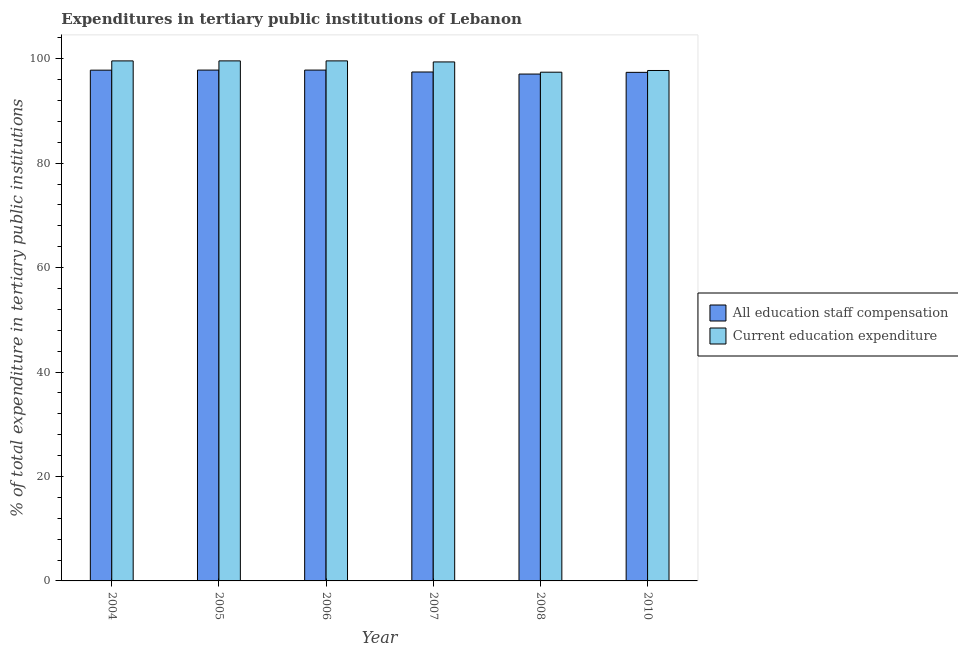How many different coloured bars are there?
Provide a succinct answer. 2. How many bars are there on the 5th tick from the left?
Ensure brevity in your answer.  2. In how many cases, is the number of bars for a given year not equal to the number of legend labels?
Offer a very short reply. 0. What is the expenditure in education in 2008?
Your answer should be very brief. 97.41. Across all years, what is the maximum expenditure in staff compensation?
Keep it short and to the point. 97.81. Across all years, what is the minimum expenditure in staff compensation?
Your response must be concise. 97.05. In which year was the expenditure in staff compensation maximum?
Your answer should be compact. 2005. What is the total expenditure in education in the graph?
Provide a succinct answer. 593.24. What is the difference between the expenditure in education in 2005 and that in 2010?
Your answer should be very brief. 1.84. What is the difference between the expenditure in education in 2005 and the expenditure in staff compensation in 2010?
Your answer should be very brief. 1.84. What is the average expenditure in education per year?
Make the answer very short. 98.87. What is the ratio of the expenditure in education in 2006 to that in 2008?
Ensure brevity in your answer.  1.02. Is the expenditure in staff compensation in 2004 less than that in 2006?
Provide a succinct answer. Yes. Is the difference between the expenditure in staff compensation in 2006 and 2007 greater than the difference between the expenditure in education in 2006 and 2007?
Offer a very short reply. No. What is the difference between the highest and the second highest expenditure in education?
Your answer should be very brief. 0. What is the difference between the highest and the lowest expenditure in education?
Your response must be concise. 2.17. What does the 2nd bar from the left in 2010 represents?
Offer a terse response. Current education expenditure. What does the 1st bar from the right in 2008 represents?
Offer a terse response. Current education expenditure. Are all the bars in the graph horizontal?
Provide a short and direct response. No. What is the difference between two consecutive major ticks on the Y-axis?
Provide a succinct answer. 20. Are the values on the major ticks of Y-axis written in scientific E-notation?
Your answer should be very brief. No. Does the graph contain any zero values?
Give a very brief answer. No. Does the graph contain grids?
Your answer should be compact. No. Where does the legend appear in the graph?
Provide a short and direct response. Center right. How many legend labels are there?
Provide a succinct answer. 2. How are the legend labels stacked?
Your response must be concise. Vertical. What is the title of the graph?
Offer a terse response. Expenditures in tertiary public institutions of Lebanon. Does "Frequency of shipment arrival" appear as one of the legend labels in the graph?
Make the answer very short. No. What is the label or title of the Y-axis?
Provide a short and direct response. % of total expenditure in tertiary public institutions. What is the % of total expenditure in tertiary public institutions in All education staff compensation in 2004?
Your response must be concise. 97.8. What is the % of total expenditure in tertiary public institutions in Current education expenditure in 2004?
Keep it short and to the point. 99.57. What is the % of total expenditure in tertiary public institutions in All education staff compensation in 2005?
Provide a succinct answer. 97.81. What is the % of total expenditure in tertiary public institutions of Current education expenditure in 2005?
Your response must be concise. 99.58. What is the % of total expenditure in tertiary public institutions in All education staff compensation in 2006?
Make the answer very short. 97.81. What is the % of total expenditure in tertiary public institutions in Current education expenditure in 2006?
Provide a succinct answer. 99.58. What is the % of total expenditure in tertiary public institutions in All education staff compensation in 2007?
Offer a very short reply. 97.45. What is the % of total expenditure in tertiary public institutions in Current education expenditure in 2007?
Your answer should be very brief. 99.38. What is the % of total expenditure in tertiary public institutions of All education staff compensation in 2008?
Make the answer very short. 97.05. What is the % of total expenditure in tertiary public institutions in Current education expenditure in 2008?
Offer a terse response. 97.41. What is the % of total expenditure in tertiary public institutions of All education staff compensation in 2010?
Your answer should be very brief. 97.38. What is the % of total expenditure in tertiary public institutions in Current education expenditure in 2010?
Offer a terse response. 97.74. Across all years, what is the maximum % of total expenditure in tertiary public institutions in All education staff compensation?
Ensure brevity in your answer.  97.81. Across all years, what is the maximum % of total expenditure in tertiary public institutions of Current education expenditure?
Offer a terse response. 99.58. Across all years, what is the minimum % of total expenditure in tertiary public institutions in All education staff compensation?
Ensure brevity in your answer.  97.05. Across all years, what is the minimum % of total expenditure in tertiary public institutions in Current education expenditure?
Ensure brevity in your answer.  97.41. What is the total % of total expenditure in tertiary public institutions of All education staff compensation in the graph?
Give a very brief answer. 585.31. What is the total % of total expenditure in tertiary public institutions of Current education expenditure in the graph?
Keep it short and to the point. 593.24. What is the difference between the % of total expenditure in tertiary public institutions of All education staff compensation in 2004 and that in 2005?
Offer a terse response. -0.02. What is the difference between the % of total expenditure in tertiary public institutions of Current education expenditure in 2004 and that in 2005?
Offer a terse response. -0. What is the difference between the % of total expenditure in tertiary public institutions of All education staff compensation in 2004 and that in 2006?
Ensure brevity in your answer.  -0.02. What is the difference between the % of total expenditure in tertiary public institutions of Current education expenditure in 2004 and that in 2006?
Make the answer very short. -0. What is the difference between the % of total expenditure in tertiary public institutions of All education staff compensation in 2004 and that in 2007?
Offer a very short reply. 0.35. What is the difference between the % of total expenditure in tertiary public institutions in Current education expenditure in 2004 and that in 2007?
Offer a terse response. 0.2. What is the difference between the % of total expenditure in tertiary public institutions of All education staff compensation in 2004 and that in 2008?
Make the answer very short. 0.74. What is the difference between the % of total expenditure in tertiary public institutions in Current education expenditure in 2004 and that in 2008?
Your answer should be very brief. 2.17. What is the difference between the % of total expenditure in tertiary public institutions in All education staff compensation in 2004 and that in 2010?
Keep it short and to the point. 0.42. What is the difference between the % of total expenditure in tertiary public institutions of Current education expenditure in 2004 and that in 2010?
Your answer should be compact. 1.84. What is the difference between the % of total expenditure in tertiary public institutions in All education staff compensation in 2005 and that in 2006?
Give a very brief answer. 0. What is the difference between the % of total expenditure in tertiary public institutions in All education staff compensation in 2005 and that in 2007?
Ensure brevity in your answer.  0.37. What is the difference between the % of total expenditure in tertiary public institutions in Current education expenditure in 2005 and that in 2007?
Ensure brevity in your answer.  0.2. What is the difference between the % of total expenditure in tertiary public institutions in All education staff compensation in 2005 and that in 2008?
Your answer should be very brief. 0.76. What is the difference between the % of total expenditure in tertiary public institutions in Current education expenditure in 2005 and that in 2008?
Offer a very short reply. 2.17. What is the difference between the % of total expenditure in tertiary public institutions of All education staff compensation in 2005 and that in 2010?
Your answer should be compact. 0.43. What is the difference between the % of total expenditure in tertiary public institutions in Current education expenditure in 2005 and that in 2010?
Provide a short and direct response. 1.84. What is the difference between the % of total expenditure in tertiary public institutions in All education staff compensation in 2006 and that in 2007?
Provide a short and direct response. 0.37. What is the difference between the % of total expenditure in tertiary public institutions in Current education expenditure in 2006 and that in 2007?
Your response must be concise. 0.2. What is the difference between the % of total expenditure in tertiary public institutions of All education staff compensation in 2006 and that in 2008?
Your response must be concise. 0.76. What is the difference between the % of total expenditure in tertiary public institutions of Current education expenditure in 2006 and that in 2008?
Ensure brevity in your answer.  2.17. What is the difference between the % of total expenditure in tertiary public institutions of All education staff compensation in 2006 and that in 2010?
Give a very brief answer. 0.43. What is the difference between the % of total expenditure in tertiary public institutions in Current education expenditure in 2006 and that in 2010?
Ensure brevity in your answer.  1.84. What is the difference between the % of total expenditure in tertiary public institutions in All education staff compensation in 2007 and that in 2008?
Your response must be concise. 0.39. What is the difference between the % of total expenditure in tertiary public institutions of Current education expenditure in 2007 and that in 2008?
Provide a succinct answer. 1.97. What is the difference between the % of total expenditure in tertiary public institutions of All education staff compensation in 2007 and that in 2010?
Ensure brevity in your answer.  0.07. What is the difference between the % of total expenditure in tertiary public institutions of Current education expenditure in 2007 and that in 2010?
Your answer should be compact. 1.64. What is the difference between the % of total expenditure in tertiary public institutions in All education staff compensation in 2008 and that in 2010?
Your answer should be compact. -0.33. What is the difference between the % of total expenditure in tertiary public institutions in Current education expenditure in 2008 and that in 2010?
Offer a very short reply. -0.33. What is the difference between the % of total expenditure in tertiary public institutions in All education staff compensation in 2004 and the % of total expenditure in tertiary public institutions in Current education expenditure in 2005?
Offer a very short reply. -1.78. What is the difference between the % of total expenditure in tertiary public institutions of All education staff compensation in 2004 and the % of total expenditure in tertiary public institutions of Current education expenditure in 2006?
Keep it short and to the point. -1.78. What is the difference between the % of total expenditure in tertiary public institutions in All education staff compensation in 2004 and the % of total expenditure in tertiary public institutions in Current education expenditure in 2007?
Give a very brief answer. -1.58. What is the difference between the % of total expenditure in tertiary public institutions of All education staff compensation in 2004 and the % of total expenditure in tertiary public institutions of Current education expenditure in 2008?
Your answer should be very brief. 0.39. What is the difference between the % of total expenditure in tertiary public institutions in All education staff compensation in 2004 and the % of total expenditure in tertiary public institutions in Current education expenditure in 2010?
Offer a very short reply. 0.06. What is the difference between the % of total expenditure in tertiary public institutions of All education staff compensation in 2005 and the % of total expenditure in tertiary public institutions of Current education expenditure in 2006?
Ensure brevity in your answer.  -1.76. What is the difference between the % of total expenditure in tertiary public institutions in All education staff compensation in 2005 and the % of total expenditure in tertiary public institutions in Current education expenditure in 2007?
Make the answer very short. -1.56. What is the difference between the % of total expenditure in tertiary public institutions of All education staff compensation in 2005 and the % of total expenditure in tertiary public institutions of Current education expenditure in 2008?
Offer a terse response. 0.41. What is the difference between the % of total expenditure in tertiary public institutions of All education staff compensation in 2005 and the % of total expenditure in tertiary public institutions of Current education expenditure in 2010?
Offer a terse response. 0.08. What is the difference between the % of total expenditure in tertiary public institutions in All education staff compensation in 2006 and the % of total expenditure in tertiary public institutions in Current education expenditure in 2007?
Provide a short and direct response. -1.56. What is the difference between the % of total expenditure in tertiary public institutions in All education staff compensation in 2006 and the % of total expenditure in tertiary public institutions in Current education expenditure in 2008?
Provide a succinct answer. 0.41. What is the difference between the % of total expenditure in tertiary public institutions of All education staff compensation in 2006 and the % of total expenditure in tertiary public institutions of Current education expenditure in 2010?
Provide a succinct answer. 0.08. What is the difference between the % of total expenditure in tertiary public institutions of All education staff compensation in 2007 and the % of total expenditure in tertiary public institutions of Current education expenditure in 2008?
Your response must be concise. 0.04. What is the difference between the % of total expenditure in tertiary public institutions of All education staff compensation in 2007 and the % of total expenditure in tertiary public institutions of Current education expenditure in 2010?
Ensure brevity in your answer.  -0.29. What is the difference between the % of total expenditure in tertiary public institutions in All education staff compensation in 2008 and the % of total expenditure in tertiary public institutions in Current education expenditure in 2010?
Your response must be concise. -0.68. What is the average % of total expenditure in tertiary public institutions of All education staff compensation per year?
Offer a very short reply. 97.55. What is the average % of total expenditure in tertiary public institutions in Current education expenditure per year?
Offer a terse response. 98.87. In the year 2004, what is the difference between the % of total expenditure in tertiary public institutions in All education staff compensation and % of total expenditure in tertiary public institutions in Current education expenditure?
Provide a succinct answer. -1.78. In the year 2005, what is the difference between the % of total expenditure in tertiary public institutions of All education staff compensation and % of total expenditure in tertiary public institutions of Current education expenditure?
Provide a succinct answer. -1.76. In the year 2006, what is the difference between the % of total expenditure in tertiary public institutions in All education staff compensation and % of total expenditure in tertiary public institutions in Current education expenditure?
Give a very brief answer. -1.76. In the year 2007, what is the difference between the % of total expenditure in tertiary public institutions in All education staff compensation and % of total expenditure in tertiary public institutions in Current education expenditure?
Offer a very short reply. -1.93. In the year 2008, what is the difference between the % of total expenditure in tertiary public institutions of All education staff compensation and % of total expenditure in tertiary public institutions of Current education expenditure?
Provide a succinct answer. -0.35. In the year 2010, what is the difference between the % of total expenditure in tertiary public institutions of All education staff compensation and % of total expenditure in tertiary public institutions of Current education expenditure?
Give a very brief answer. -0.36. What is the ratio of the % of total expenditure in tertiary public institutions in Current education expenditure in 2004 to that in 2006?
Your response must be concise. 1. What is the ratio of the % of total expenditure in tertiary public institutions of All education staff compensation in 2004 to that in 2007?
Your answer should be very brief. 1. What is the ratio of the % of total expenditure in tertiary public institutions of All education staff compensation in 2004 to that in 2008?
Your answer should be very brief. 1.01. What is the ratio of the % of total expenditure in tertiary public institutions of Current education expenditure in 2004 to that in 2008?
Your response must be concise. 1.02. What is the ratio of the % of total expenditure in tertiary public institutions of Current education expenditure in 2004 to that in 2010?
Offer a terse response. 1.02. What is the ratio of the % of total expenditure in tertiary public institutions of All education staff compensation in 2005 to that in 2007?
Your response must be concise. 1. What is the ratio of the % of total expenditure in tertiary public institutions of Current education expenditure in 2005 to that in 2007?
Your answer should be very brief. 1. What is the ratio of the % of total expenditure in tertiary public institutions of Current education expenditure in 2005 to that in 2008?
Ensure brevity in your answer.  1.02. What is the ratio of the % of total expenditure in tertiary public institutions of Current education expenditure in 2005 to that in 2010?
Your answer should be very brief. 1.02. What is the ratio of the % of total expenditure in tertiary public institutions in All education staff compensation in 2006 to that in 2007?
Provide a short and direct response. 1. What is the ratio of the % of total expenditure in tertiary public institutions in All education staff compensation in 2006 to that in 2008?
Offer a very short reply. 1.01. What is the ratio of the % of total expenditure in tertiary public institutions in Current education expenditure in 2006 to that in 2008?
Offer a very short reply. 1.02. What is the ratio of the % of total expenditure in tertiary public institutions of Current education expenditure in 2006 to that in 2010?
Make the answer very short. 1.02. What is the ratio of the % of total expenditure in tertiary public institutions in All education staff compensation in 2007 to that in 2008?
Offer a terse response. 1. What is the ratio of the % of total expenditure in tertiary public institutions in Current education expenditure in 2007 to that in 2008?
Offer a terse response. 1.02. What is the ratio of the % of total expenditure in tertiary public institutions in Current education expenditure in 2007 to that in 2010?
Your answer should be compact. 1.02. What is the ratio of the % of total expenditure in tertiary public institutions in All education staff compensation in 2008 to that in 2010?
Provide a succinct answer. 1. What is the ratio of the % of total expenditure in tertiary public institutions of Current education expenditure in 2008 to that in 2010?
Make the answer very short. 1. What is the difference between the highest and the second highest % of total expenditure in tertiary public institutions in All education staff compensation?
Provide a succinct answer. 0. What is the difference between the highest and the second highest % of total expenditure in tertiary public institutions of Current education expenditure?
Provide a succinct answer. 0. What is the difference between the highest and the lowest % of total expenditure in tertiary public institutions in All education staff compensation?
Provide a short and direct response. 0.76. What is the difference between the highest and the lowest % of total expenditure in tertiary public institutions in Current education expenditure?
Ensure brevity in your answer.  2.17. 